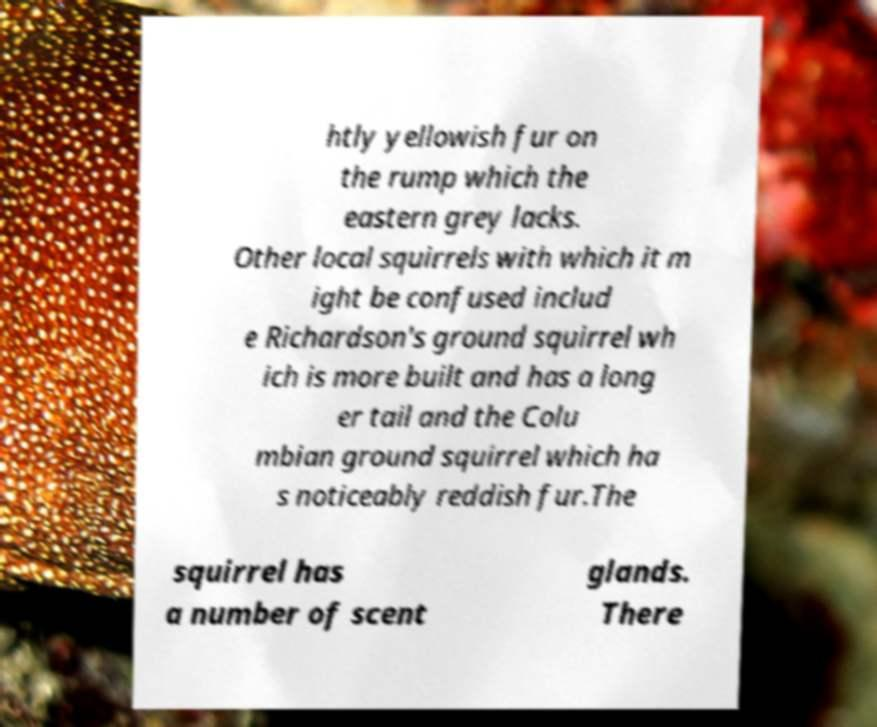Can you accurately transcribe the text from the provided image for me? htly yellowish fur on the rump which the eastern grey lacks. Other local squirrels with which it m ight be confused includ e Richardson's ground squirrel wh ich is more built and has a long er tail and the Colu mbian ground squirrel which ha s noticeably reddish fur.The squirrel has a number of scent glands. There 